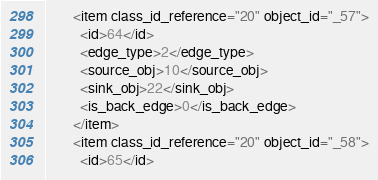<code> <loc_0><loc_0><loc_500><loc_500><_Ada_>        <item class_id_reference="20" object_id="_57">
          <id>64</id>
          <edge_type>2</edge_type>
          <source_obj>10</source_obj>
          <sink_obj>22</sink_obj>
          <is_back_edge>0</is_back_edge>
        </item>
        <item class_id_reference="20" object_id="_58">
          <id>65</id></code> 